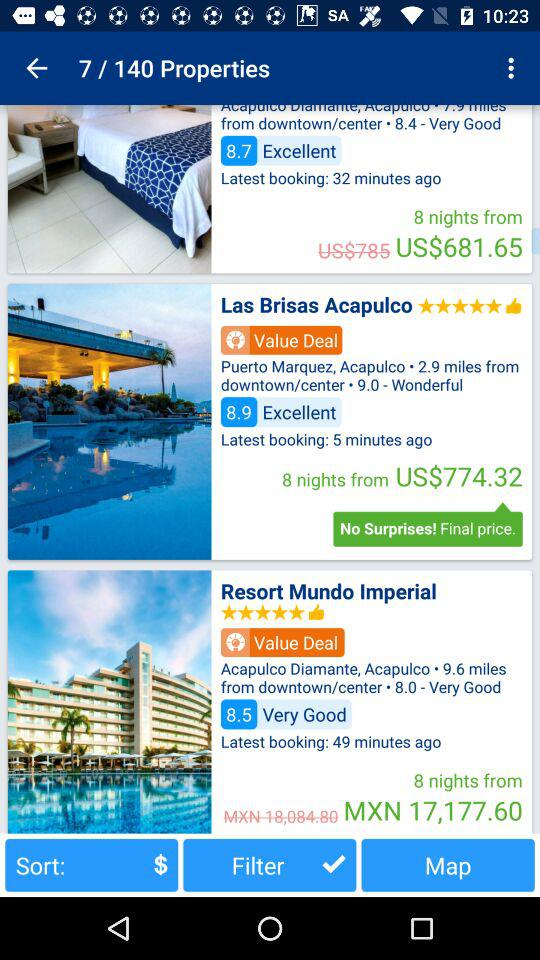Which hotel has the highest price per night?
Answer the question using a single word or phrase. Resort Mundo Imperial 